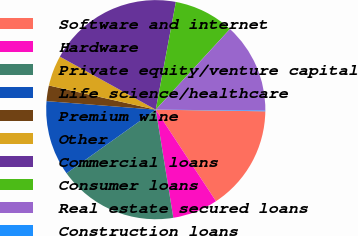Convert chart. <chart><loc_0><loc_0><loc_500><loc_500><pie_chart><fcel>Software and internet<fcel>Hardware<fcel>Private equity/venture capital<fcel>Life science/healthcare<fcel>Premium wine<fcel>Other<fcel>Commercial loans<fcel>Consumer loans<fcel>Real estate secured loans<fcel>Construction loans<nl><fcel>15.5%<fcel>6.7%<fcel>17.7%<fcel>11.1%<fcel>2.3%<fcel>4.5%<fcel>19.9%<fcel>8.9%<fcel>13.3%<fcel>0.1%<nl></chart> 